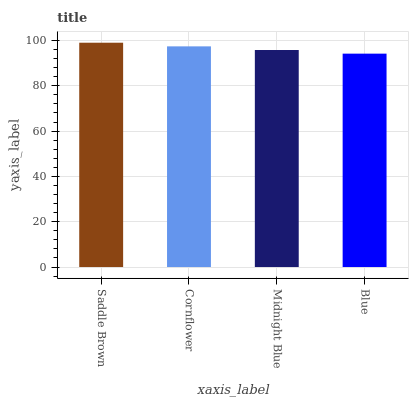Is Blue the minimum?
Answer yes or no. Yes. Is Saddle Brown the maximum?
Answer yes or no. Yes. Is Cornflower the minimum?
Answer yes or no. No. Is Cornflower the maximum?
Answer yes or no. No. Is Saddle Brown greater than Cornflower?
Answer yes or no. Yes. Is Cornflower less than Saddle Brown?
Answer yes or no. Yes. Is Cornflower greater than Saddle Brown?
Answer yes or no. No. Is Saddle Brown less than Cornflower?
Answer yes or no. No. Is Cornflower the high median?
Answer yes or no. Yes. Is Midnight Blue the low median?
Answer yes or no. Yes. Is Midnight Blue the high median?
Answer yes or no. No. Is Blue the low median?
Answer yes or no. No. 